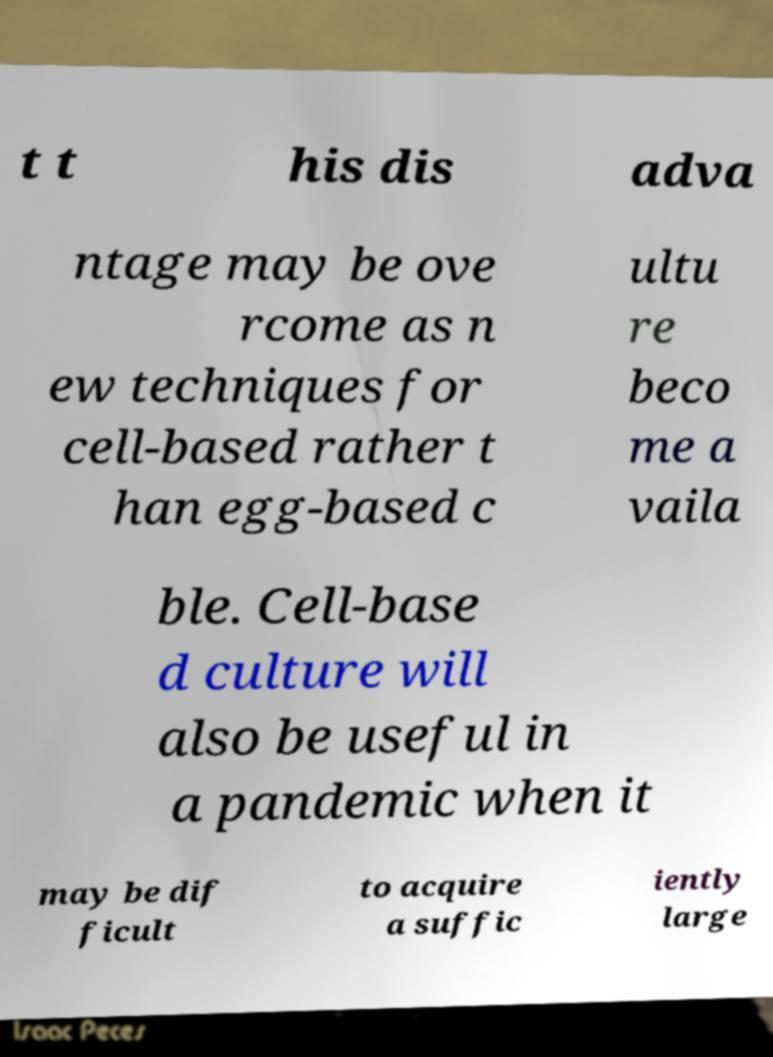There's text embedded in this image that I need extracted. Can you transcribe it verbatim? t t his dis adva ntage may be ove rcome as n ew techniques for cell-based rather t han egg-based c ultu re beco me a vaila ble. Cell-base d culture will also be useful in a pandemic when it may be dif ficult to acquire a suffic iently large 